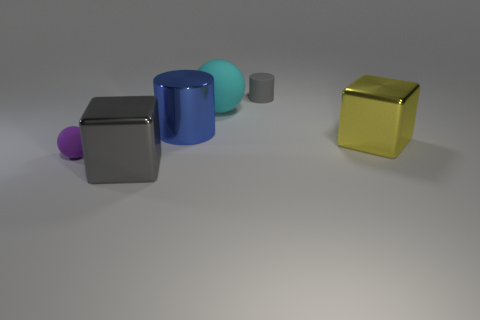There is a thing that is both to the right of the tiny ball and on the left side of the blue metal cylinder; what is its color?
Give a very brief answer. Gray. Is the number of cyan matte balls that are right of the tiny gray rubber thing greater than the number of tiny spheres in front of the tiny purple rubber ball?
Provide a short and direct response. No. There is a matte ball that is behind the purple rubber thing; what color is it?
Make the answer very short. Cyan. Do the small matte object that is left of the shiny cylinder and the gray thing behind the large gray block have the same shape?
Provide a succinct answer. No. Are there any metal cylinders of the same size as the cyan ball?
Give a very brief answer. Yes. What is the material of the big cube that is in front of the yellow metal block?
Provide a succinct answer. Metal. Are the large cube right of the large blue metallic object and the small purple object made of the same material?
Keep it short and to the point. No. Is there a small yellow sphere?
Your answer should be compact. No. The big thing that is the same material as the purple sphere is what color?
Your response must be concise. Cyan. What color is the cylinder behind the matte sphere that is to the right of the tiny rubber thing that is to the left of the big shiny cylinder?
Your answer should be compact. Gray. 